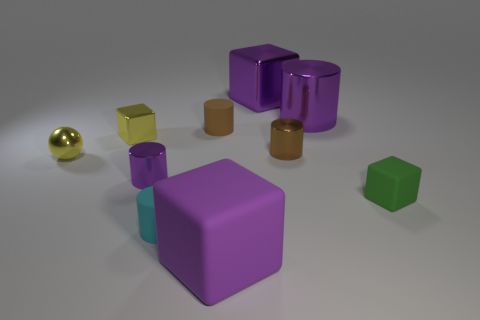What is the material of the other cube that is the same color as the big rubber block?
Ensure brevity in your answer.  Metal. Are there any purple objects that have the same shape as the small cyan object?
Keep it short and to the point. Yes. What shape is the rubber object that is right of the cube that is in front of the small green block?
Keep it short and to the point. Cube. What shape is the tiny cyan object?
Your response must be concise. Cylinder. What is the cylinder that is in front of the purple metallic thing that is on the left side of the large purple thing in front of the small yellow cube made of?
Offer a very short reply. Rubber. How many other objects are the same material as the tiny yellow ball?
Ensure brevity in your answer.  5. How many cubes are in front of the rubber cylinder that is behind the tiny shiny ball?
Offer a terse response. 3. What number of cubes are big rubber things or purple things?
Provide a short and direct response. 2. What color is the rubber object that is in front of the tiny sphere and behind the tiny cyan cylinder?
Your answer should be compact. Green. Is there any other thing that is the same color as the tiny shiny ball?
Make the answer very short. Yes. 